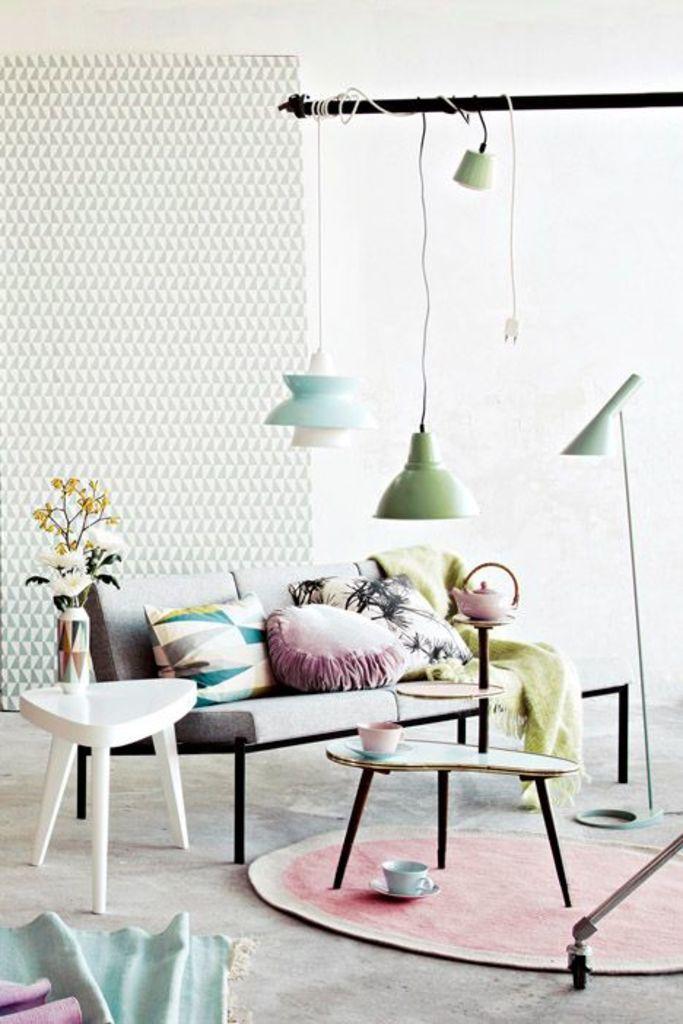Could you give a brief overview of what you see in this image? At the bottom middle, there is a sofa on which cushions and blanket is kept. In front of that table is there on that a cup is there. And left side a table is there on which flower vase is kept. The background is white in color. And lamps are hanged on the pole which are attached to the wall. This image is taken inside a house. 